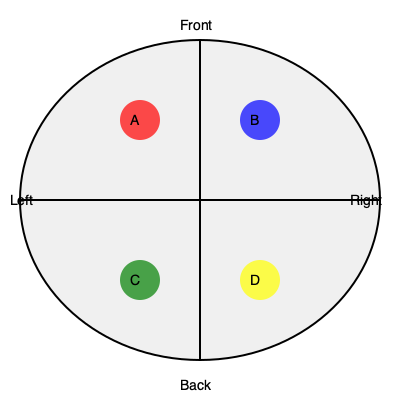In the simplified brain cross-section above, which labeled area (A, B, C, or D) most likely represents the location of a lesion causing visual field defects? To answer this question, we need to consider the anatomy of the brain and the visual processing pathway:

1. The brain is divided into four lobes: frontal, parietal, temporal, and occipital.
2. The occipital lobe, located at the back of the brain, is primarily responsible for visual processing.
3. In the given cross-section:
   - A and B are in the front (anterior) part of the brain.
   - C and D are in the back (posterior) part of the brain.
4. Visual information from the eyes is processed in the occipital lobe.
5. Lesions in the occipital lobe can cause various visual field defects, such as hemianopia or quadrantanopia.
6. Among the labeled areas, C and D are located in the posterior region, corresponding to the occipital lobe.
7. Both C and D could potentially cause visual field defects if lesioned, but D is more centrally located in the occipital region.

Therefore, area D is most likely to represent the location of a lesion causing visual field defects.
Answer: D 